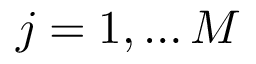Convert formula to latex. <formula><loc_0><loc_0><loc_500><loc_500>j = 1 , \dots M</formula> 